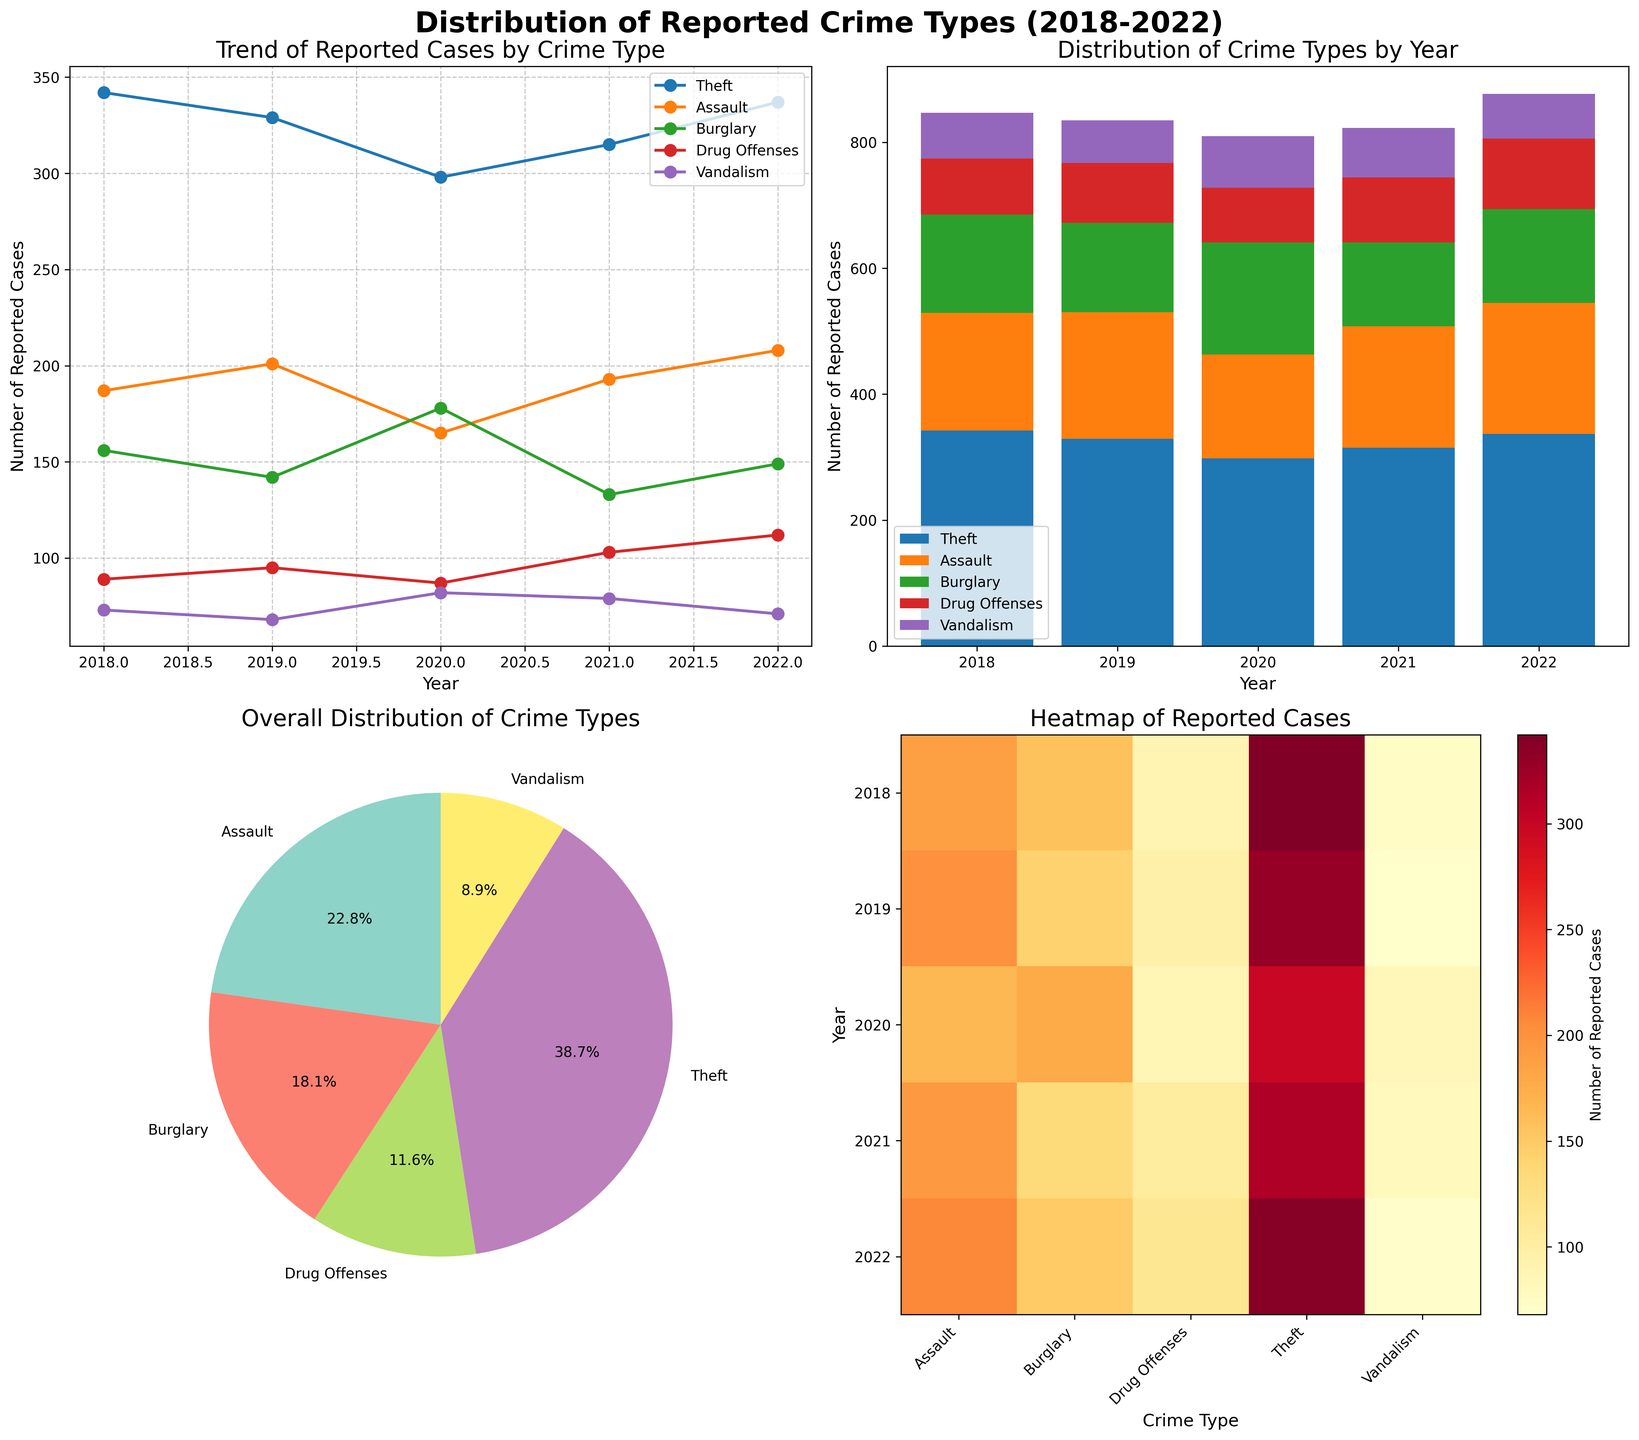What is the title of the line plot? The title of the line plot is mentioned on top of the corresponding subplot.
Answer: Trend of Reported Cases by Crime Type Which crime type had the highest number of reported cases in 2022 according to the line plot? By looking at the line for each crime type in 2022, the highest point corresponds to the crime type Theft.
Answer: Theft In the stacked bar plot, which year had the overall highest number of reported crime cases? By looking at the heights of the bars for each year, the tallest bar represents the year with the highest number of crime cases, which is 2018.
Answer: 2018 What percentage of the overall reported crimes from 2018-2022 were Drug Offenses according to the pie chart? Observing the slices of the pie chart, the percentage for Drug Offenses is labeled directly on the chart and is 9.9%.
Answer: 9.9% How many reported cases of Assault were there in 2020 according to the heatmap? The color intensity for Assault in 2020 can be traced to the corresponding value on the heatmap, which is 165.
Answer: 165 Which crime type showed a decreasing trend from 2018 to 2019 in the line plot? By examining the direction of the lines for each crime type from 2018 to 2019, the line for Vandalism decreases during this period.
Answer: Vandalism Compare the number of reported Burglary cases between 2018 and 2021. Which year had more cases? Referring to the heights of the lines or bars for Burglary in 2018 and 2021, there are more cases in 2018 than in 2021.
Answer: 2018 What is the overall distribution of Vandalism across all the years depicted in the heatmap? The heatmap shows colored cells for Vandalism from 2018 to 2022, with the values indicating the number of cases 73, 68, 82, 79, and 71, respectively.
Answer: 73, 68, 82, 79, 71 Which crime type has the smallest total number of reported cases from 2018 to 2022 according to the pie chart? Observing the smallest slice in the pie chart, the crime with the smallest total is Vandalism.
Answer: Vandalism 